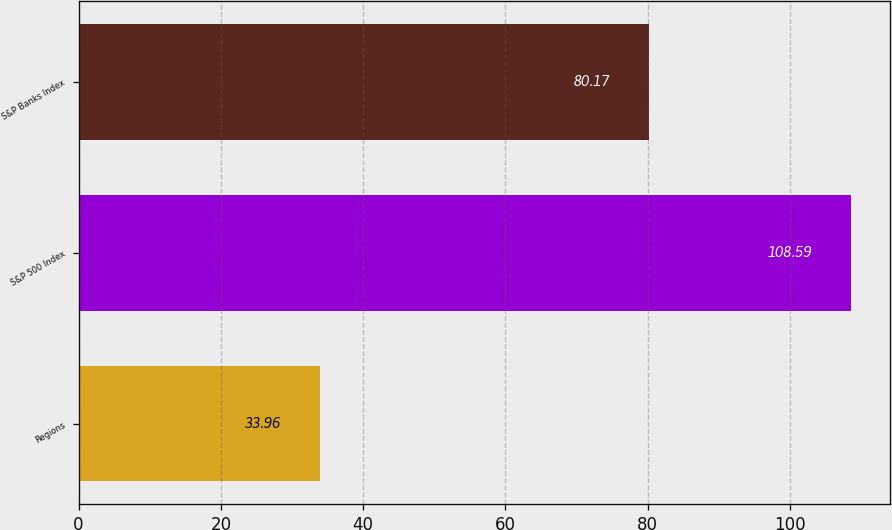<chart> <loc_0><loc_0><loc_500><loc_500><bar_chart><fcel>Regions<fcel>S&P 500 Index<fcel>S&P Banks Index<nl><fcel>33.96<fcel>108.59<fcel>80.17<nl></chart> 